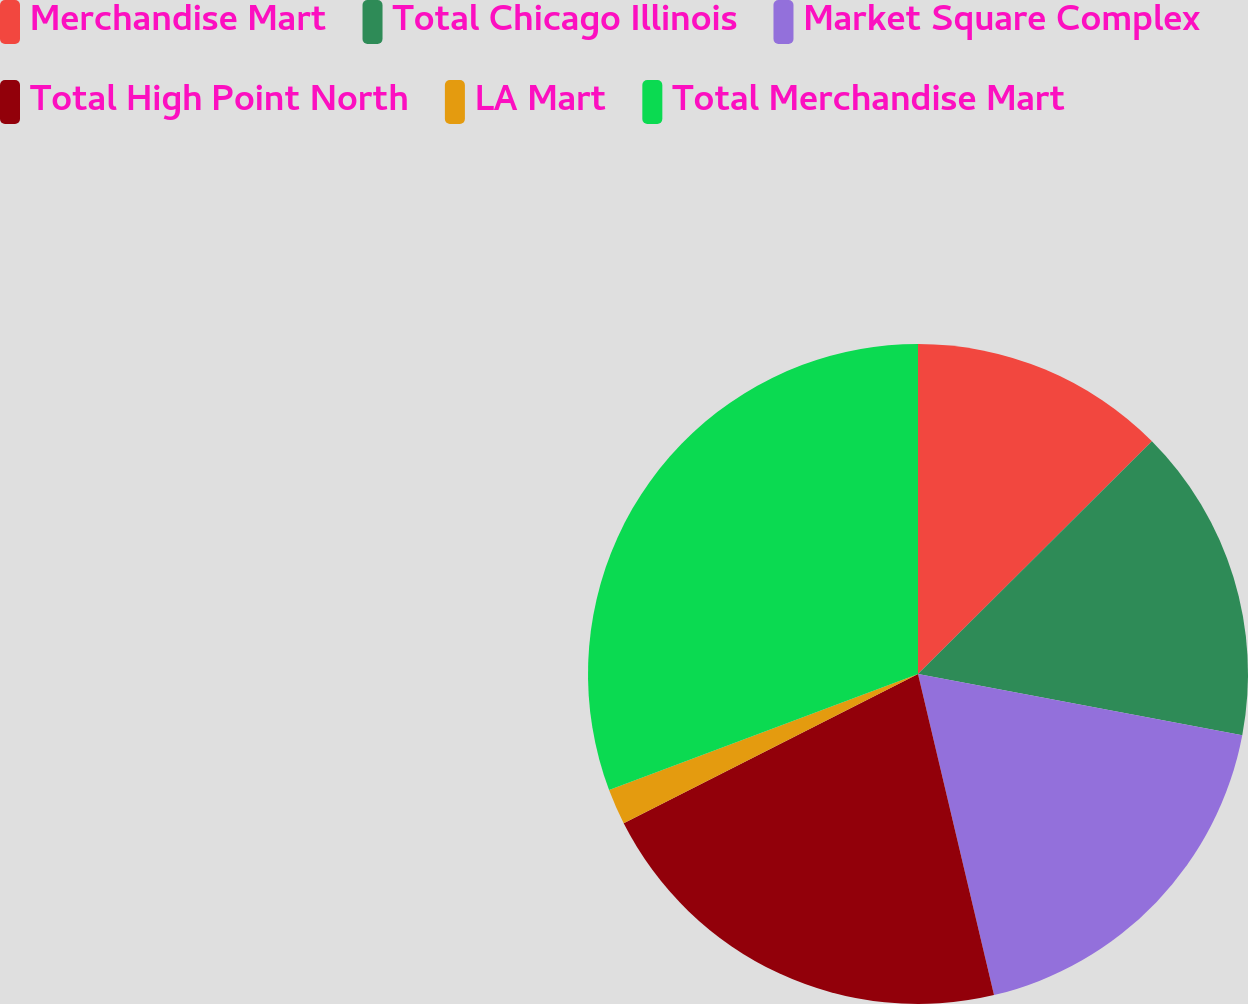Convert chart. <chart><loc_0><loc_0><loc_500><loc_500><pie_chart><fcel>Merchandise Mart<fcel>Total Chicago Illinois<fcel>Market Square Complex<fcel>Total High Point North<fcel>LA Mart<fcel>Total Merchandise Mart<nl><fcel>12.54%<fcel>15.43%<fcel>18.33%<fcel>21.23%<fcel>1.75%<fcel>30.72%<nl></chart> 